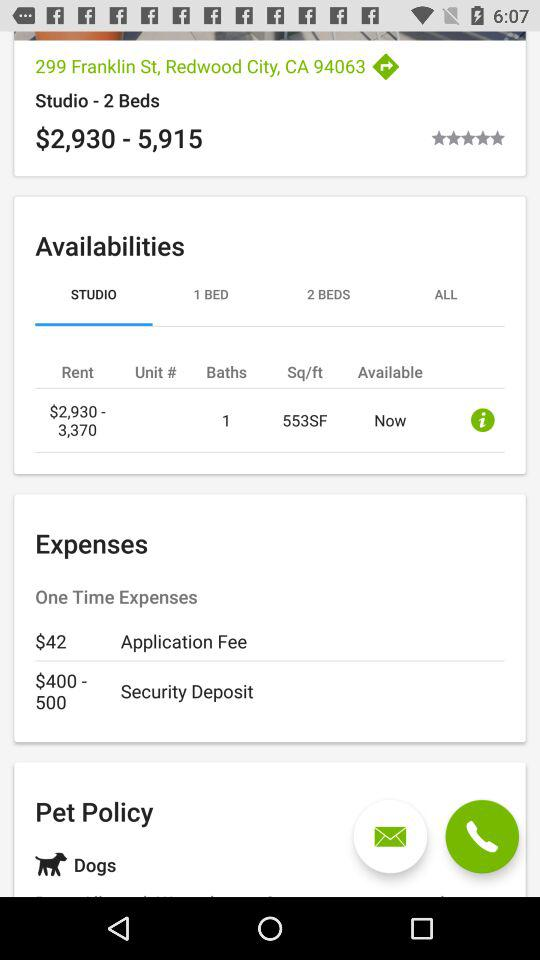What is the rent for studios? The rent for studios is $2,930–$3,370. 